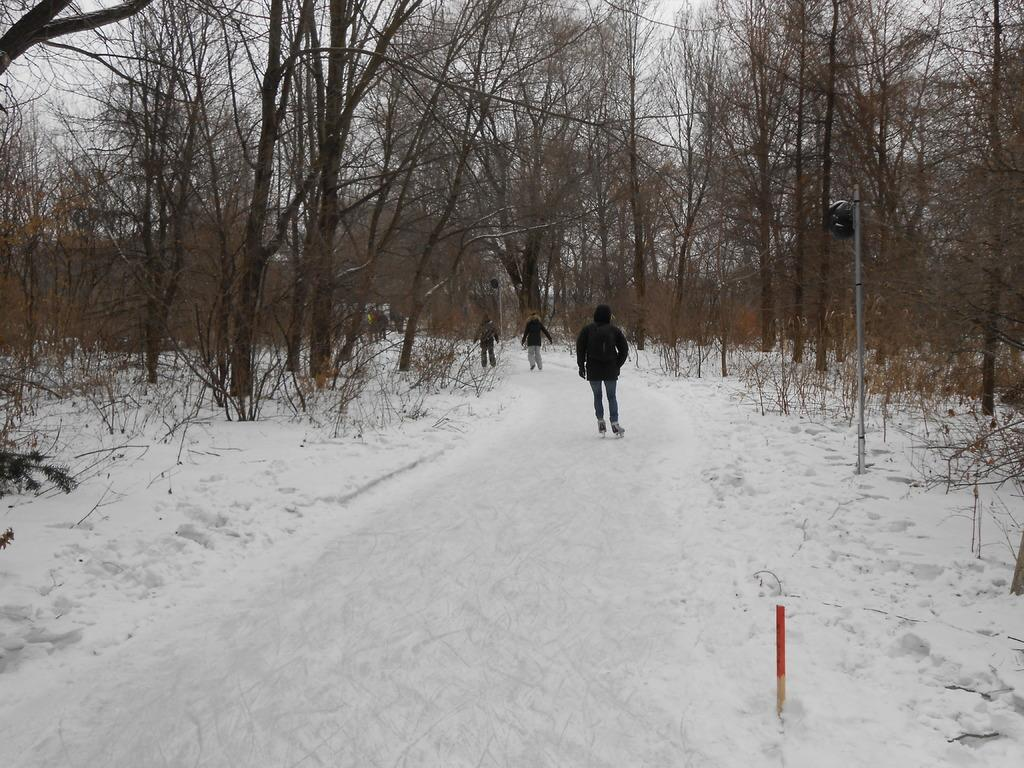How many people are in the image? There are three persons in the image. What are the persons doing in the image? The persons are walking on the snow. What can be seen on either side of the persons? There are dry trees on either side of the persons. What type of belief can be seen in the image? There is no specific belief depicted in the image; it shows three persons walking on the snow with dry trees on either side. 